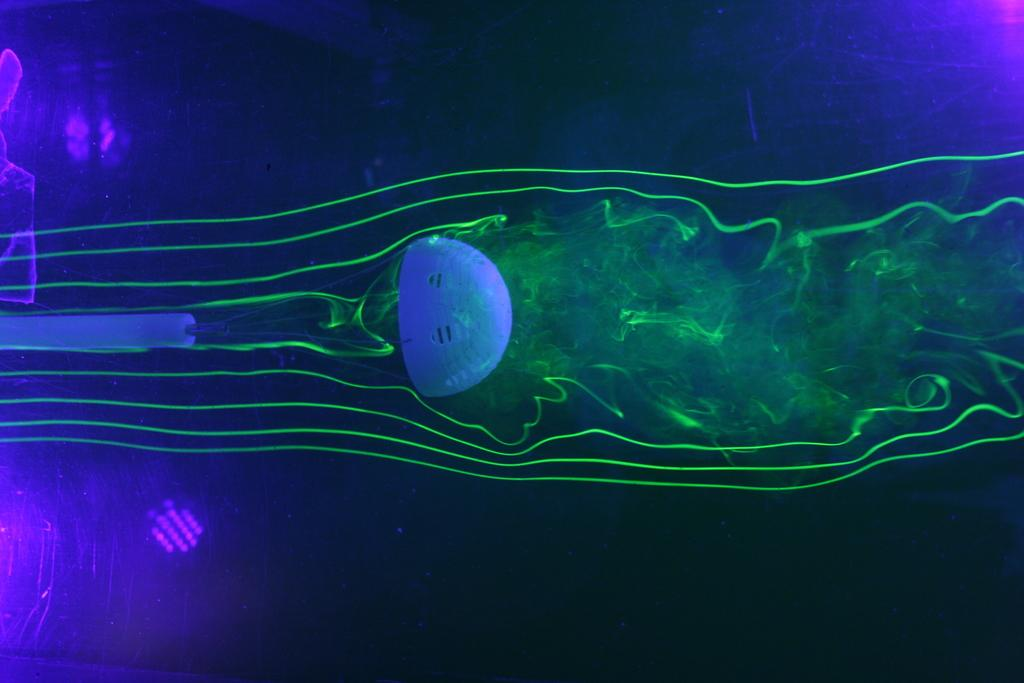What type of image is being described? The image is animated. What can be seen in the image? There is an object in the image. What color is the background of the image? The background of the image is blue. What additional detail can be observed in the image? There are green color fumes in the image. What type of seat is visible in the image? There is no seat present in the image. What is the cause of the green color fumes in the image? The cause of the green color fumes is not mentioned in the image or the provided facts. 